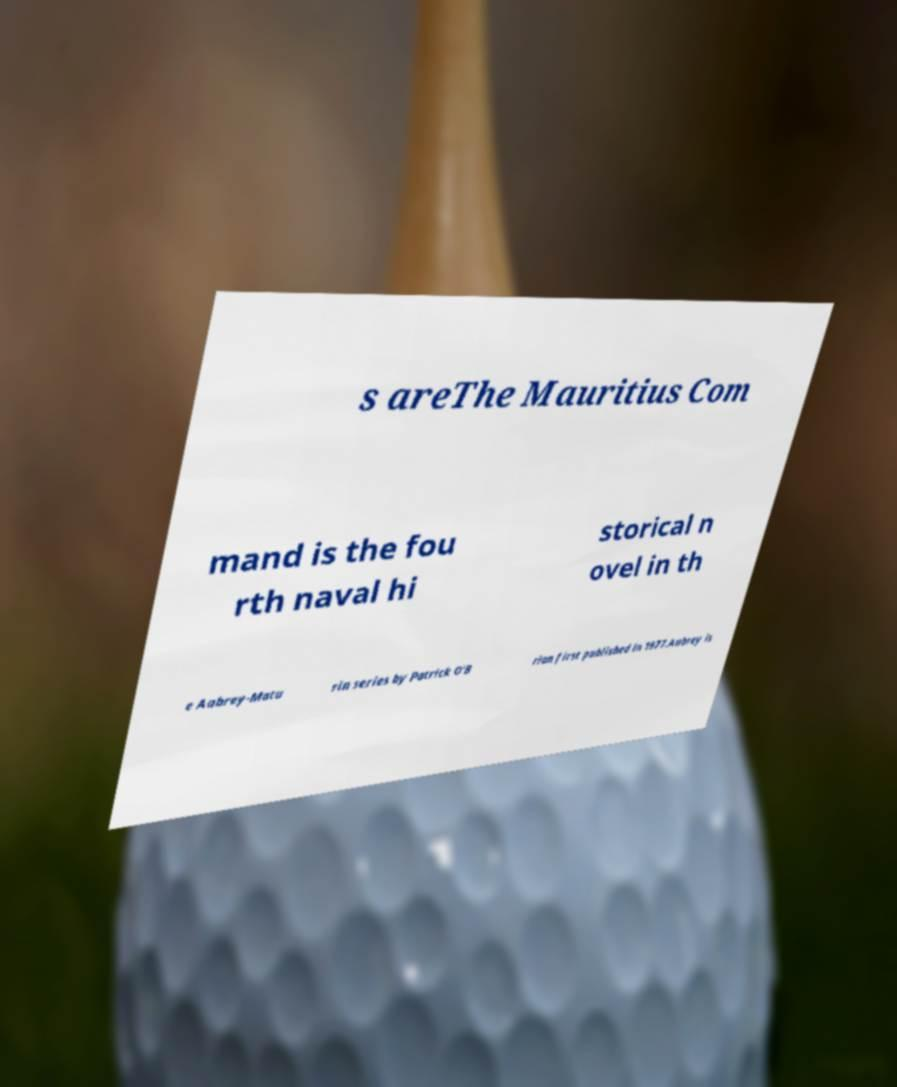There's text embedded in this image that I need extracted. Can you transcribe it verbatim? s areThe Mauritius Com mand is the fou rth naval hi storical n ovel in th e Aubrey-Matu rin series by Patrick O'B rian first published in 1977.Aubrey is 